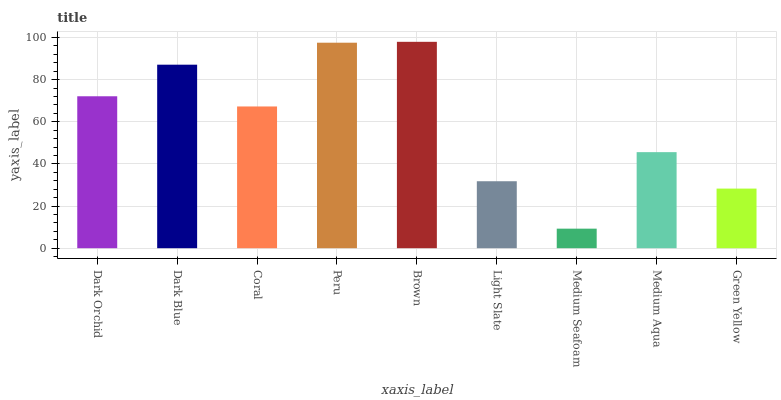Is Medium Seafoam the minimum?
Answer yes or no. Yes. Is Brown the maximum?
Answer yes or no. Yes. Is Dark Blue the minimum?
Answer yes or no. No. Is Dark Blue the maximum?
Answer yes or no. No. Is Dark Blue greater than Dark Orchid?
Answer yes or no. Yes. Is Dark Orchid less than Dark Blue?
Answer yes or no. Yes. Is Dark Orchid greater than Dark Blue?
Answer yes or no. No. Is Dark Blue less than Dark Orchid?
Answer yes or no. No. Is Coral the high median?
Answer yes or no. Yes. Is Coral the low median?
Answer yes or no. Yes. Is Light Slate the high median?
Answer yes or no. No. Is Brown the low median?
Answer yes or no. No. 